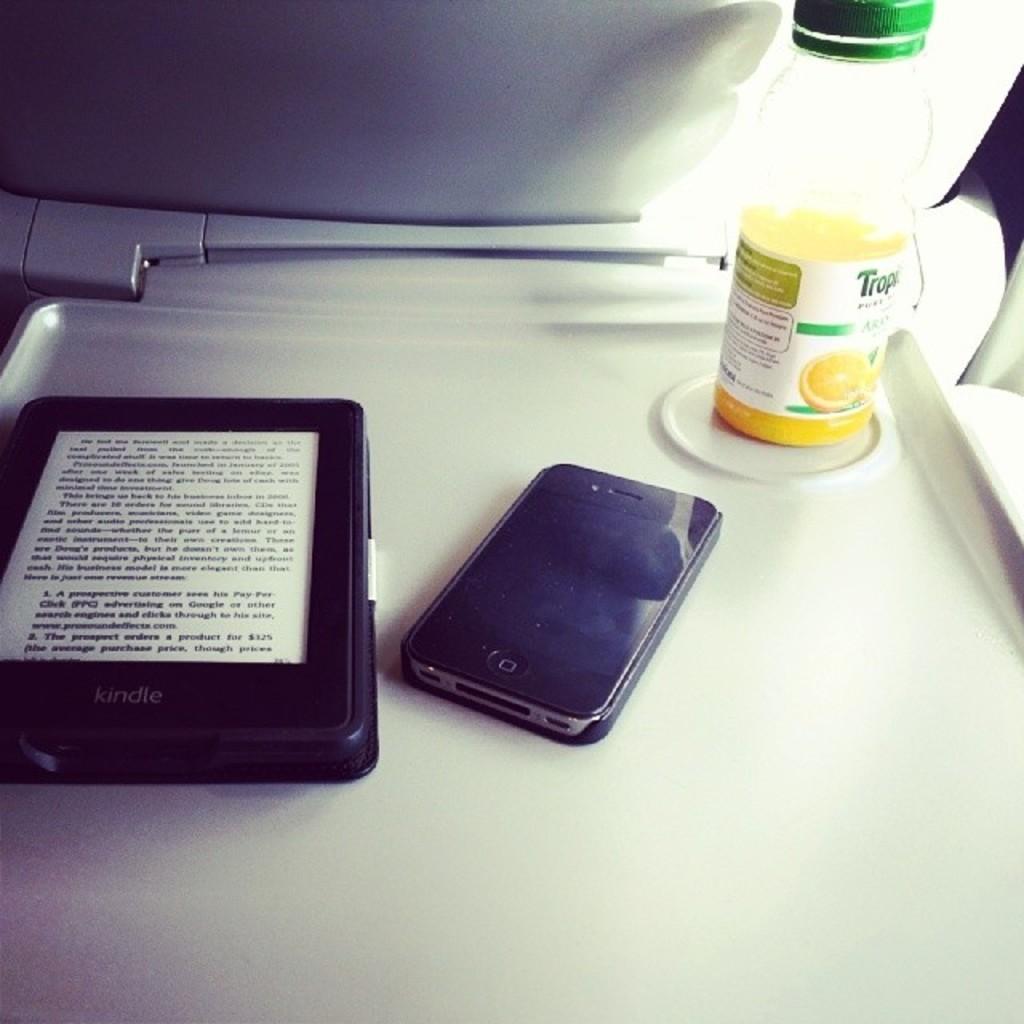What brand is the reader?
Provide a succinct answer. Kindle. 